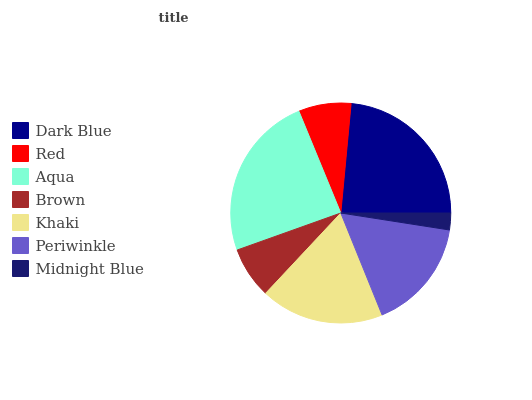Is Midnight Blue the minimum?
Answer yes or no. Yes. Is Aqua the maximum?
Answer yes or no. Yes. Is Red the minimum?
Answer yes or no. No. Is Red the maximum?
Answer yes or no. No. Is Dark Blue greater than Red?
Answer yes or no. Yes. Is Red less than Dark Blue?
Answer yes or no. Yes. Is Red greater than Dark Blue?
Answer yes or no. No. Is Dark Blue less than Red?
Answer yes or no. No. Is Periwinkle the high median?
Answer yes or no. Yes. Is Periwinkle the low median?
Answer yes or no. Yes. Is Midnight Blue the high median?
Answer yes or no. No. Is Red the low median?
Answer yes or no. No. 